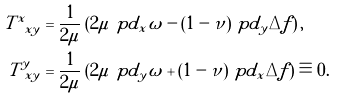<formula> <loc_0><loc_0><loc_500><loc_500>T ^ { x } _ { \ x y } & = \frac { 1 } { 2 \mu } \left ( 2 \mu \ p d _ { x } \omega - ( 1 - \nu ) \ p d _ { y } \Delta f \right ) , \\ T ^ { y } _ { \ x y } & = \frac { 1 } { 2 \mu } \left ( 2 \mu \ p d _ { y } \omega + ( 1 - \nu ) \ p d _ { x } \Delta f \right ) \equiv 0 .</formula> 